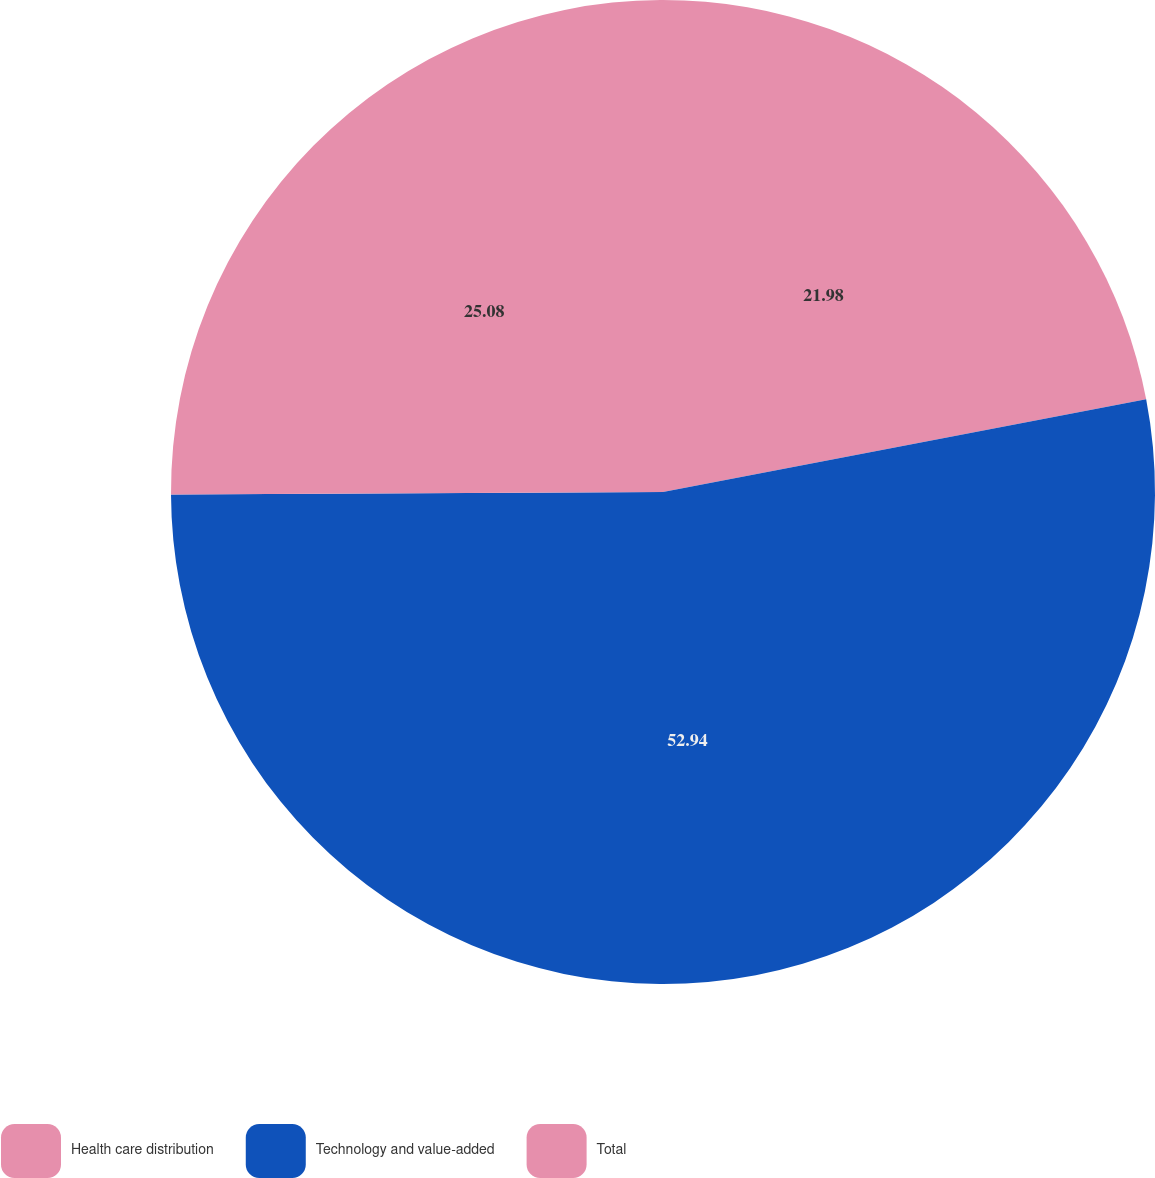Convert chart to OTSL. <chart><loc_0><loc_0><loc_500><loc_500><pie_chart><fcel>Health care distribution<fcel>Technology and value-added<fcel>Total<nl><fcel>21.98%<fcel>52.94%<fcel>25.08%<nl></chart> 